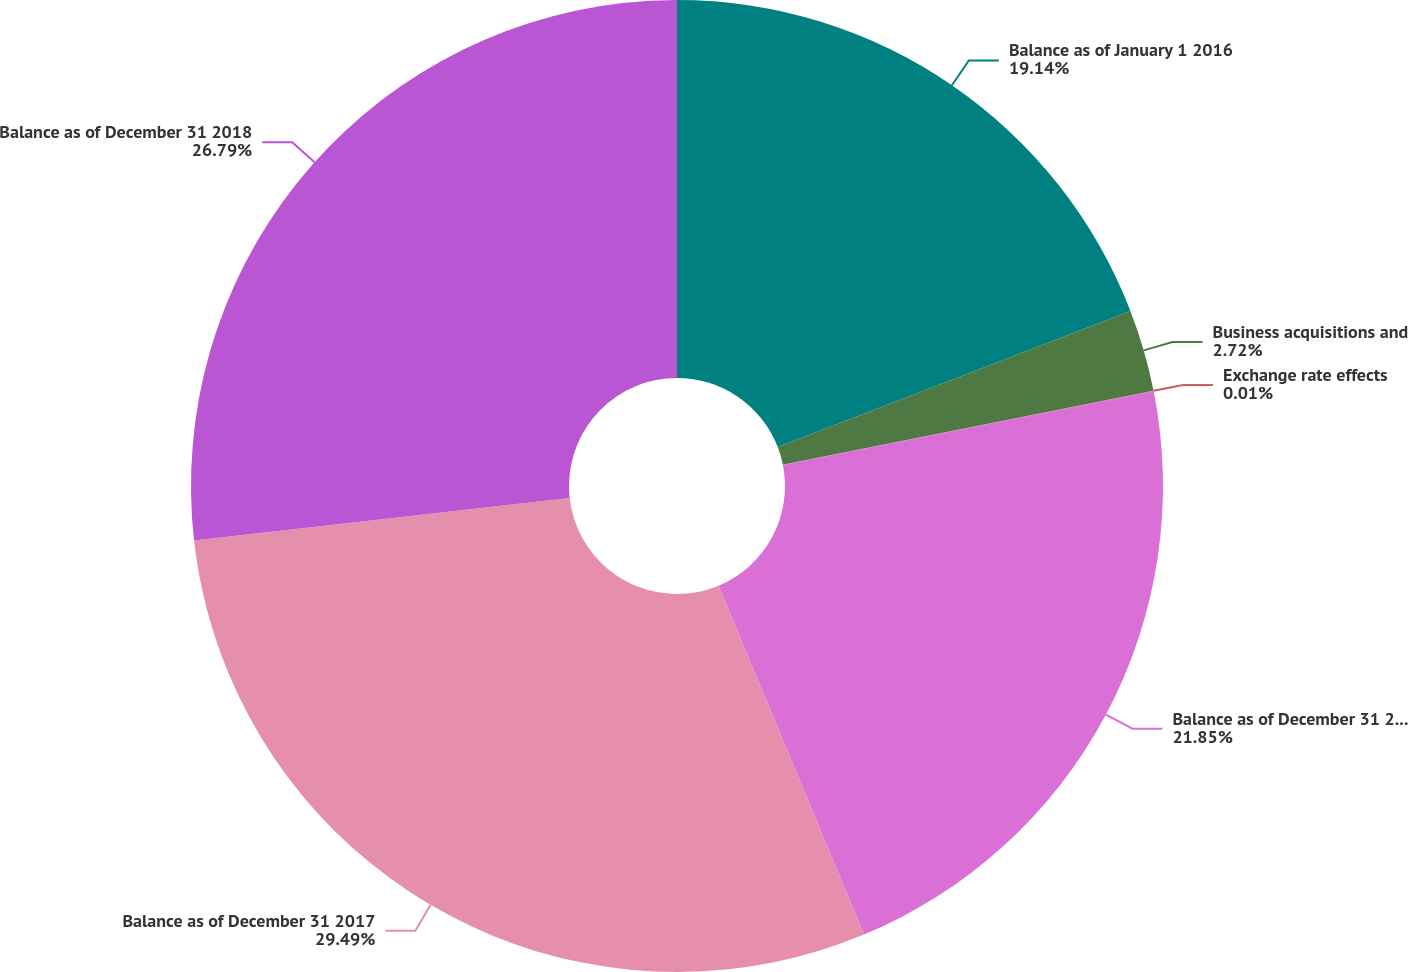Convert chart to OTSL. <chart><loc_0><loc_0><loc_500><loc_500><pie_chart><fcel>Balance as of January 1 2016<fcel>Business acquisitions and<fcel>Exchange rate effects<fcel>Balance as of December 31 2016<fcel>Balance as of December 31 2017<fcel>Balance as of December 31 2018<nl><fcel>19.14%<fcel>2.72%<fcel>0.01%<fcel>21.85%<fcel>29.5%<fcel>26.79%<nl></chart> 